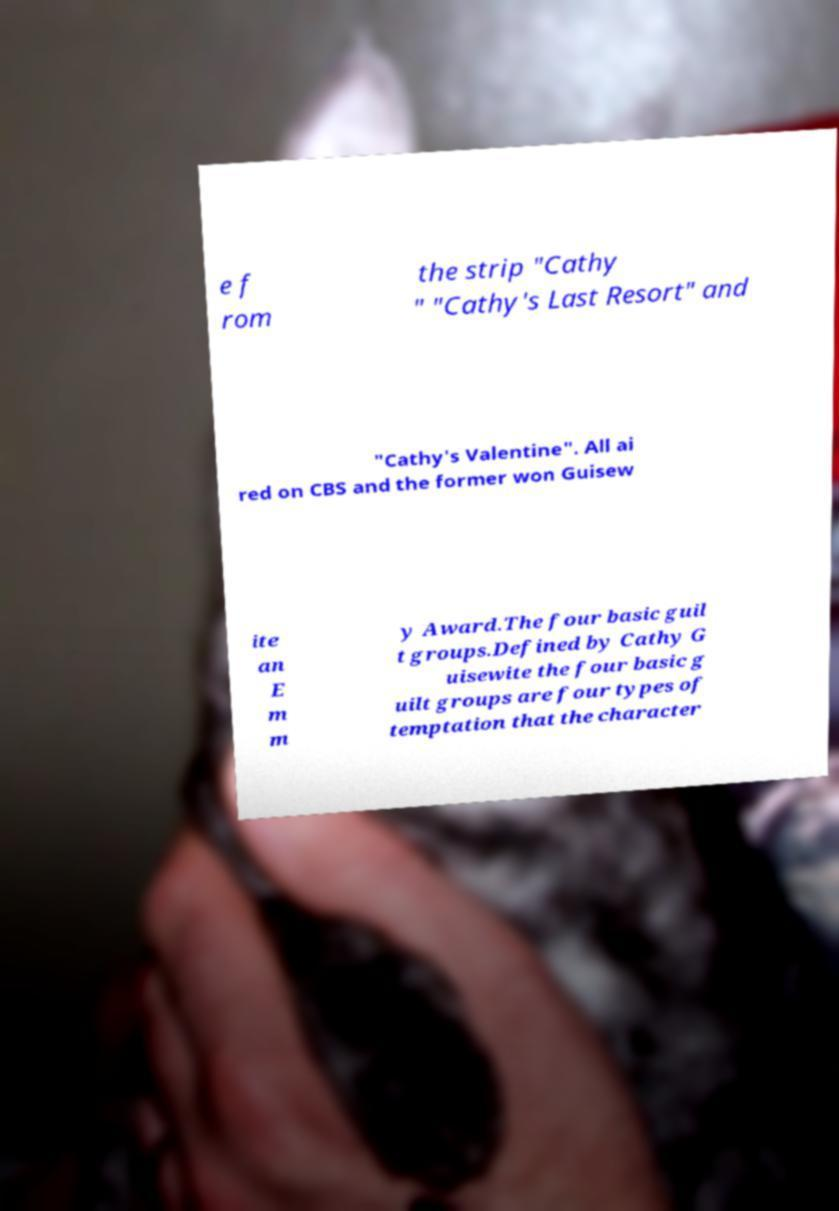What messages or text are displayed in this image? I need them in a readable, typed format. e f rom the strip "Cathy " "Cathy's Last Resort" and "Cathy's Valentine". All ai red on CBS and the former won Guisew ite an E m m y Award.The four basic guil t groups.Defined by Cathy G uisewite the four basic g uilt groups are four types of temptation that the character 